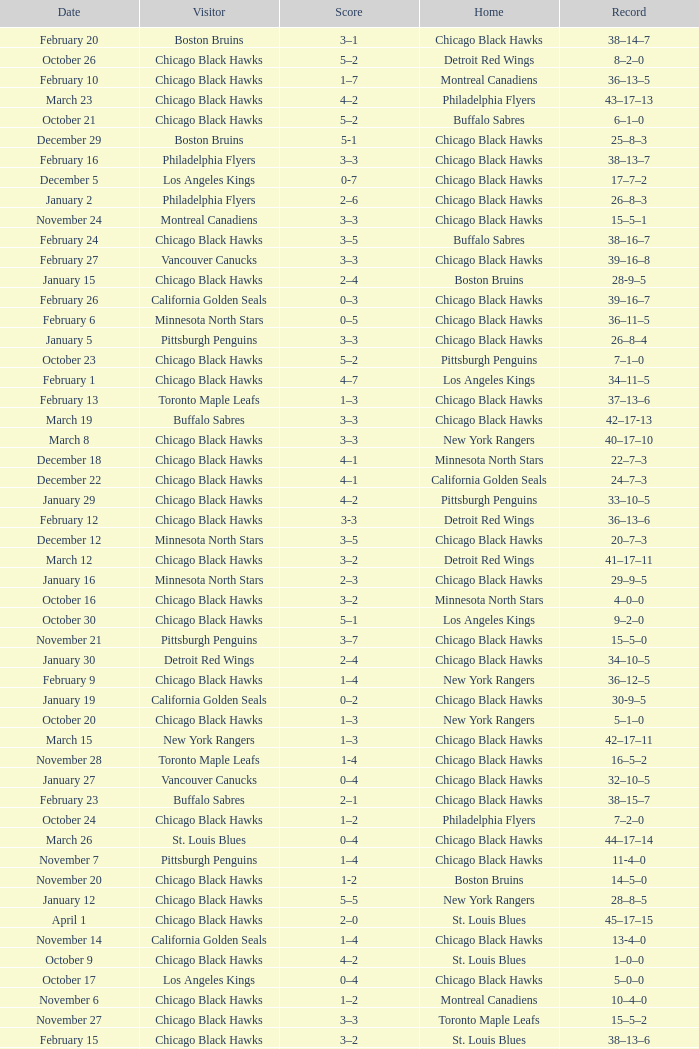What is the Score of the Chicago Black Hawks Home game with the Visiting Vancouver Canucks on November 17? 0-3. 